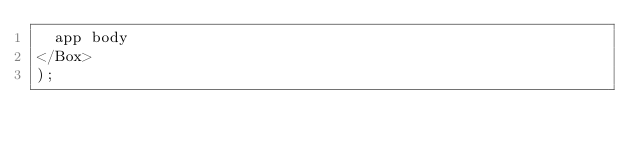<code> <loc_0><loc_0><loc_500><loc_500><_JavaScript_>  app body
</Box>
);
</code> 